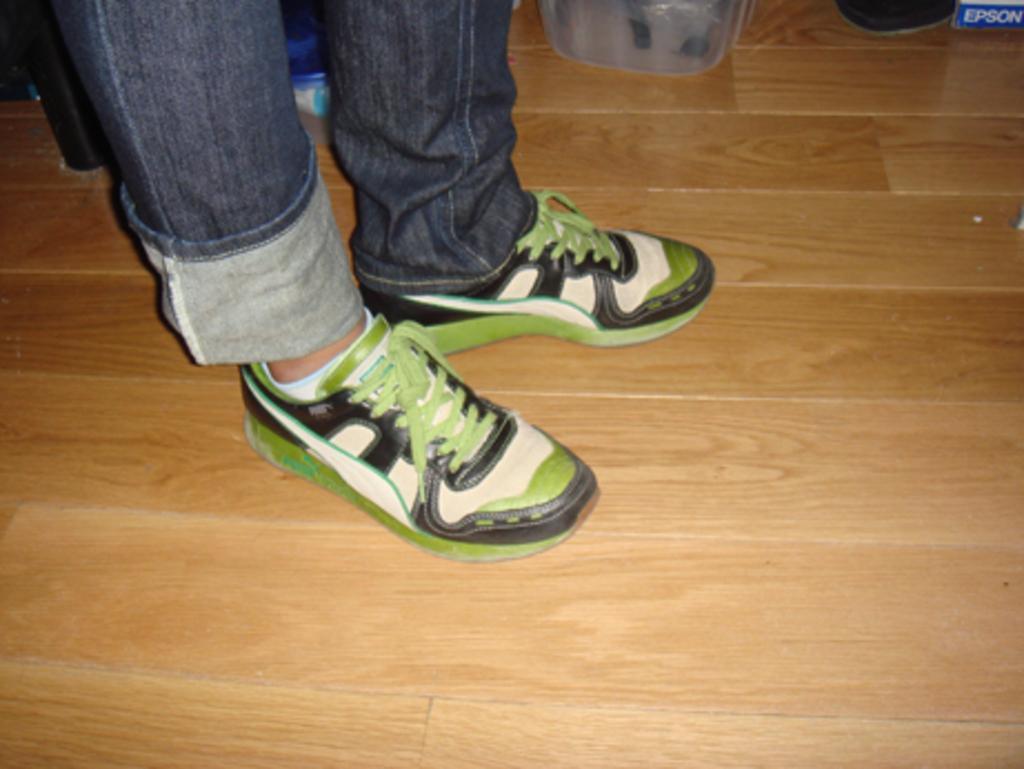How would you summarize this image in a sentence or two? We can see a person legs with shoes on a wooden floor. Also there are some items. 